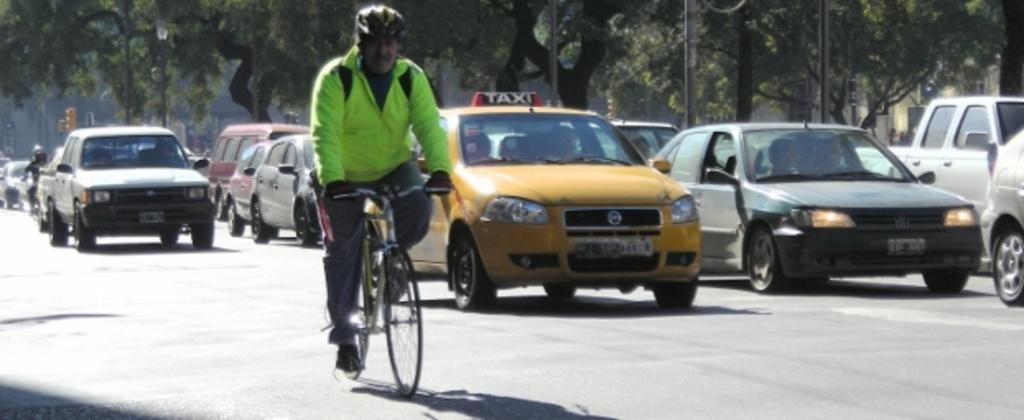<image>
Summarize the visual content of the image. A cyclist wearing a neon yellow shirt rides in front of a taxi. 